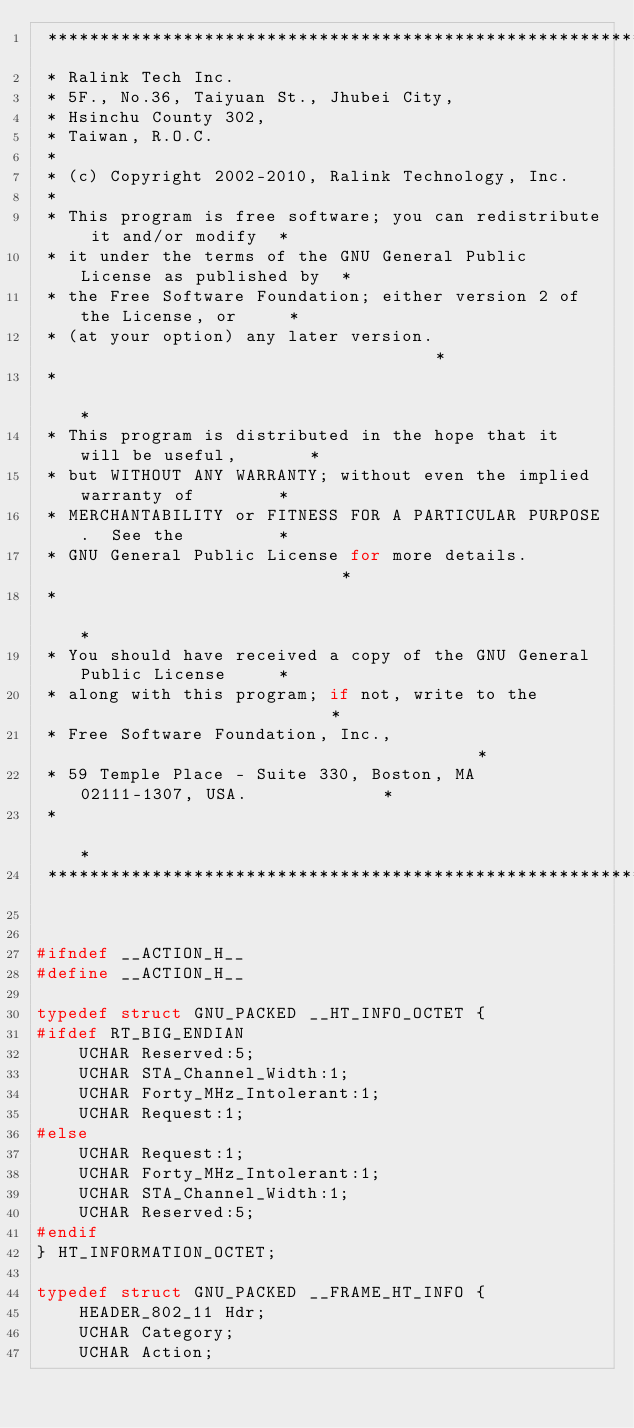<code> <loc_0><loc_0><loc_500><loc_500><_C_> *************************************************************************
 * Ralink Tech Inc.
 * 5F., No.36, Taiyuan St., Jhubei City,
 * Hsinchu County 302,
 * Taiwan, R.O.C.
 *
 * (c) Copyright 2002-2010, Ralink Technology, Inc.
 *
 * This program is free software; you can redistribute it and/or modify  *
 * it under the terms of the GNU General Public License as published by  *
 * the Free Software Foundation; either version 2 of the License, or     *
 * (at your option) any later version.                                   *
 *                                                                       *
 * This program is distributed in the hope that it will be useful,       *
 * but WITHOUT ANY WARRANTY; without even the implied warranty of        *
 * MERCHANTABILITY or FITNESS FOR A PARTICULAR PURPOSE.  See the         *
 * GNU General Public License for more details.                          *
 *                                                                       *
 * You should have received a copy of the GNU General Public License     *
 * along with this program; if not, write to the                         *
 * Free Software Foundation, Inc.,                                       *
 * 59 Temple Place - Suite 330, Boston, MA  02111-1307, USA.             *
 *                                                                       *
 *************************************************************************/


#ifndef	__ACTION_H__
#define	__ACTION_H__

typedef struct GNU_PACKED __HT_INFO_OCTET {
#ifdef RT_BIG_ENDIAN
	UCHAR Reserved:5;
	UCHAR STA_Channel_Width:1;
	UCHAR Forty_MHz_Intolerant:1;
	UCHAR Request:1;
#else
	UCHAR Request:1;
	UCHAR Forty_MHz_Intolerant:1;
	UCHAR STA_Channel_Width:1;
	UCHAR Reserved:5;
#endif
} HT_INFORMATION_OCTET;

typedef struct GNU_PACKED __FRAME_HT_INFO {
	HEADER_802_11 Hdr;
	UCHAR Category;
	UCHAR Action;</code> 